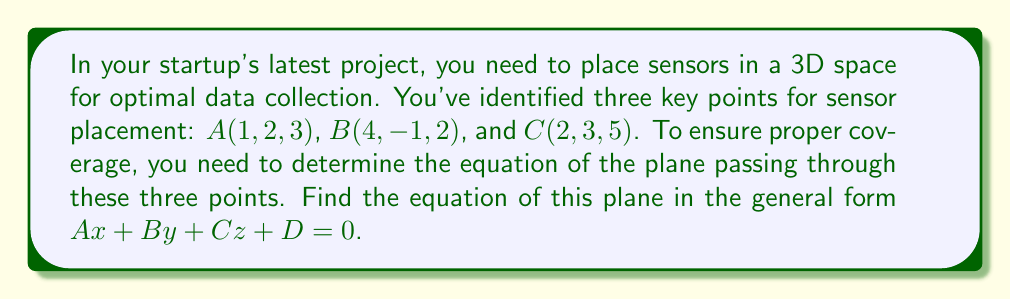Can you answer this question? To find the equation of a plane passing through three points, we'll follow these steps:

1) First, we need to find two vectors on the plane. We can do this by subtracting the coordinates of two points from the third:

   $\vec{AB} = B - A = (4-1, -1-2, 2-3) = (3, -3, -1)$
   $\vec{AC} = C - A = (2-1, 3-2, 5-3) = (1, 1, 2)$

2) The normal vector to the plane will be the cross product of these two vectors:

   $\vec{n} = \vec{AB} \times \vec{AC} = \begin{vmatrix} 
   i & j & k \\
   3 & -3 & -1 \\
   1 & 1 & 2
   \end{vmatrix}$

   $= ((-3)(2) - (-1)(1))i - ((3)(2) - (-1)(1))j + ((3)(1) - (-3)(1))k$
   
   $= (-6 + 1)i - (6 + 1)j + (3 + 3)k$
   
   $= -5i - 7j + 6k$

3) The general equation of a plane is $Ax + By + Cz + D = 0$, where $(A, B, C)$ is the normal vector. So our equation will be:

   $-5x - 7y + 6z + D = 0$

4) To find $D$, we can substitute the coordinates of any of the given points. Let's use $A(1, 2, 3)$:

   $-5(1) - 7(2) + 6(3) + D = 0$
   $-5 - 14 + 18 + D = 0$
   $-1 + D = 0$
   $D = 1$

5) Therefore, the equation of the plane is:

   $-5x - 7y + 6z + 1 = 0$
Answer: $-5x - 7y + 6z + 1 = 0$ 